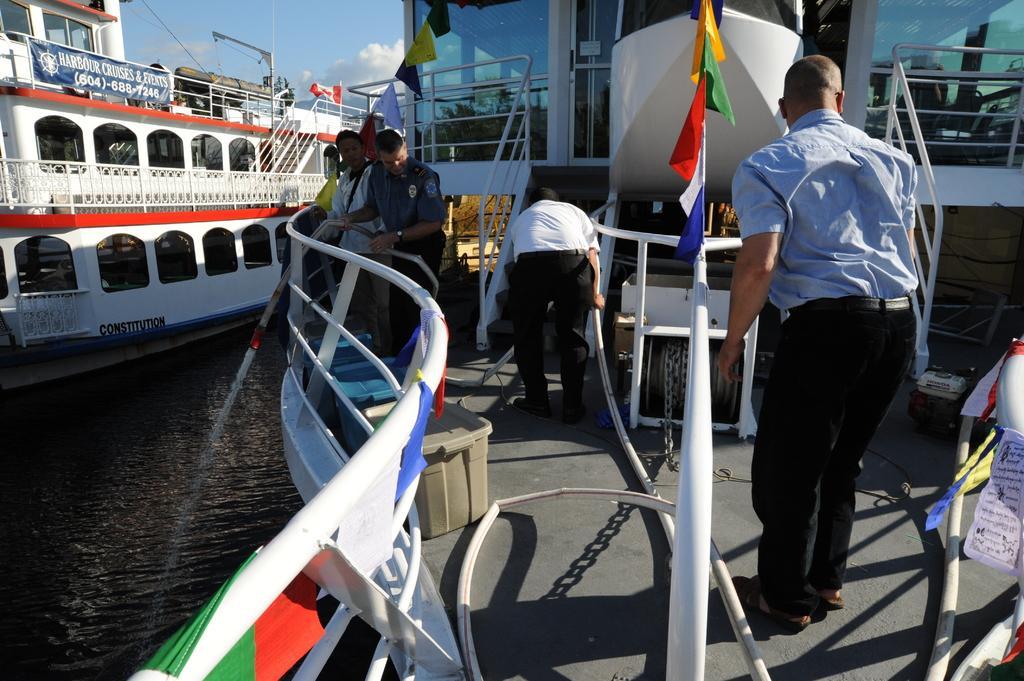Please provide a concise description of this image. In this image there is a harbor in that harbor there are two ships in one ship there are four men, in background there is a blue sky. 